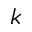<formula> <loc_0><loc_0><loc_500><loc_500>k</formula> 